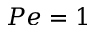Convert formula to latex. <formula><loc_0><loc_0><loc_500><loc_500>P e = 1</formula> 